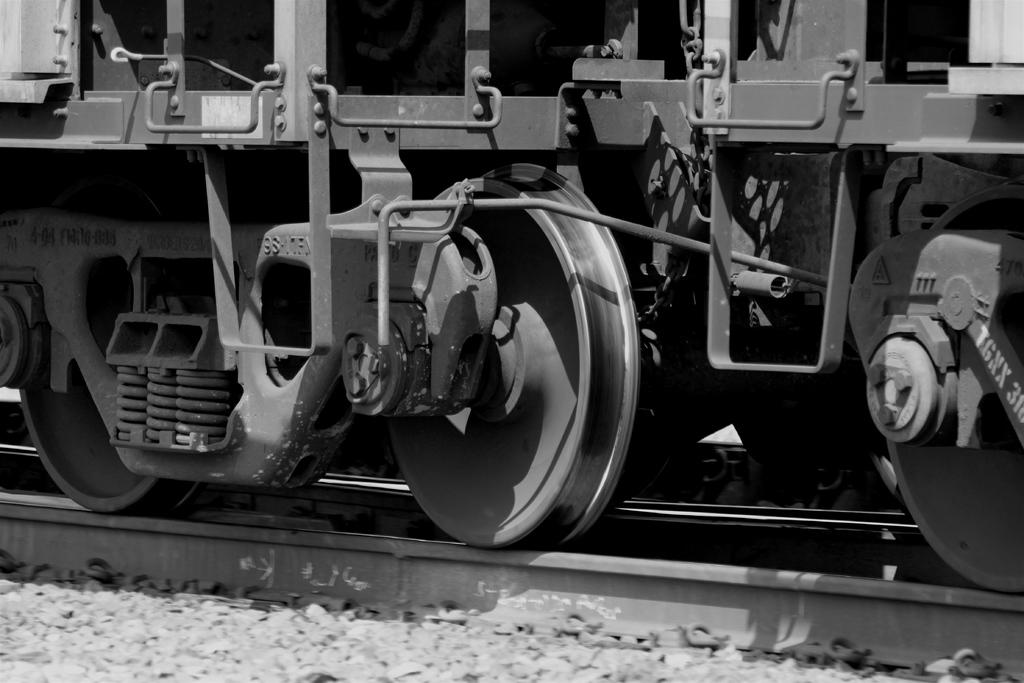What is the color scheme of the image? The image is black and white. What type of objects can be seen in the image? There are stones and a train in the image. Where is the train located in the image? The train is on a railway track in the image. How much payment is required to ride the train in the image? There is no information about payment in the image, as it only shows a train on a railway track. What type of oil is used to lubricate the train in the image? There is no mention of oil or any maintenance-related details in the image, as it only shows a train on a railway track. 